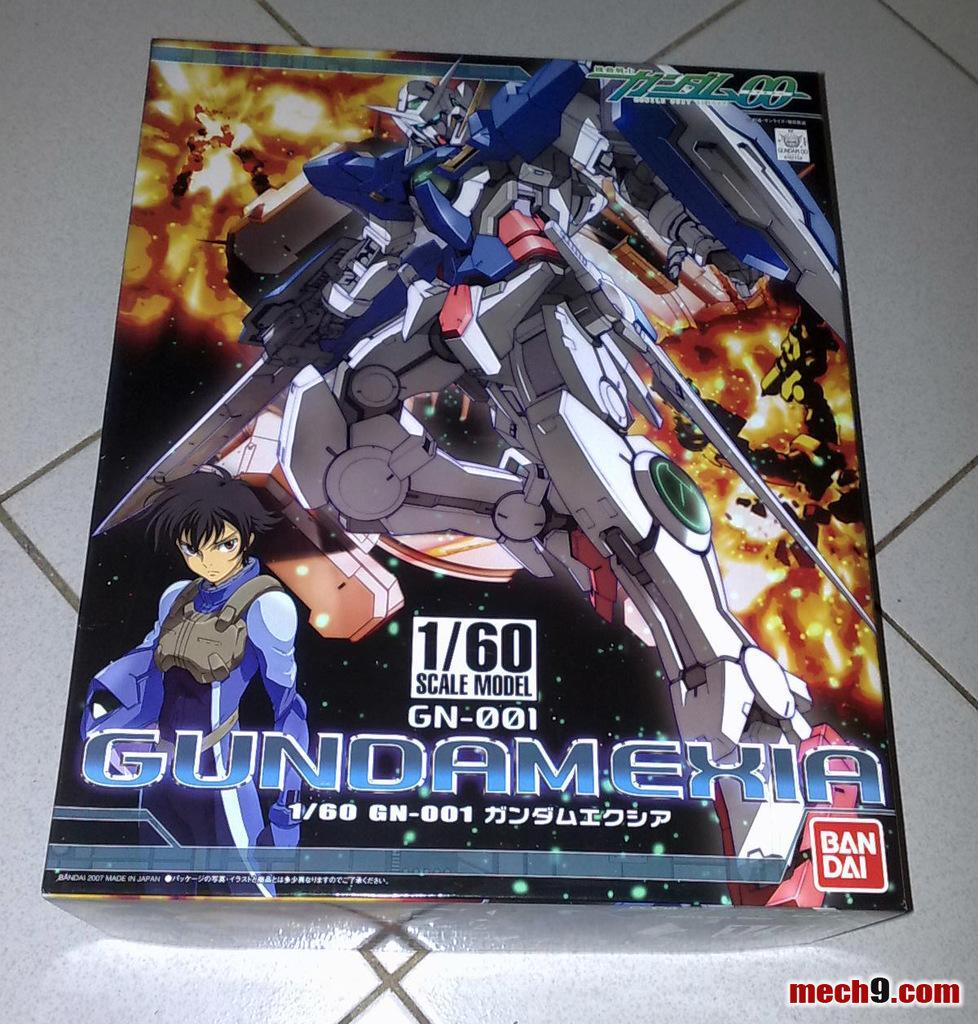Could you give a brief overview of what you see in this image? In this image I see a box on which I see the animated character and I see a transformer over here which is of white, red and blue in color and I see words and numbers written over here and I see this box is on the white floor. 